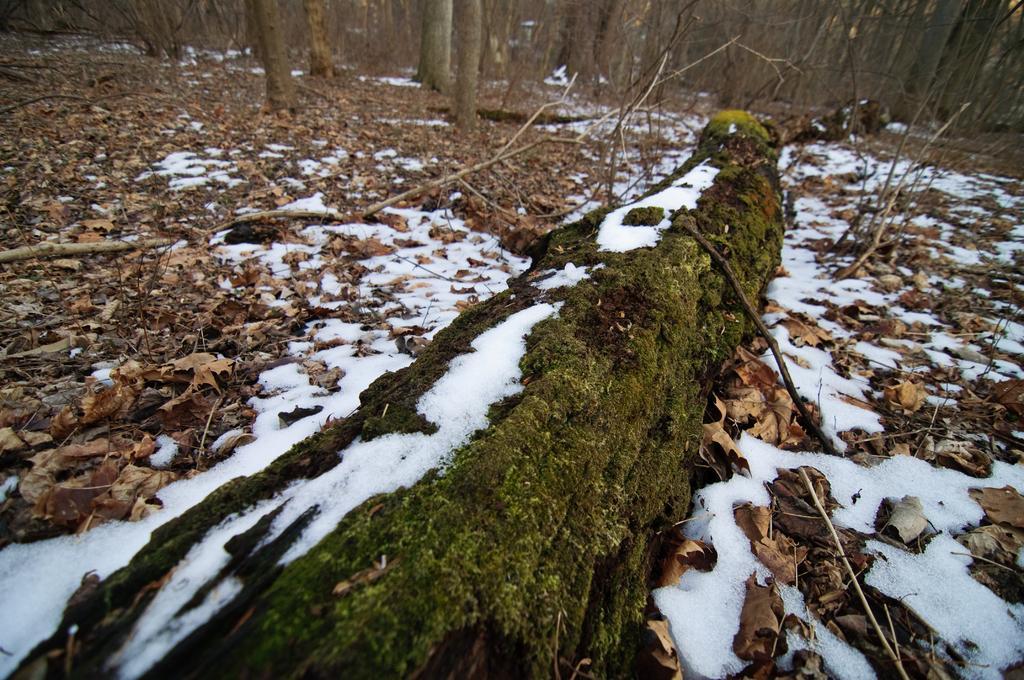In one or two sentences, can you explain what this image depicts? This is snow. There are dried leaves and trees. 